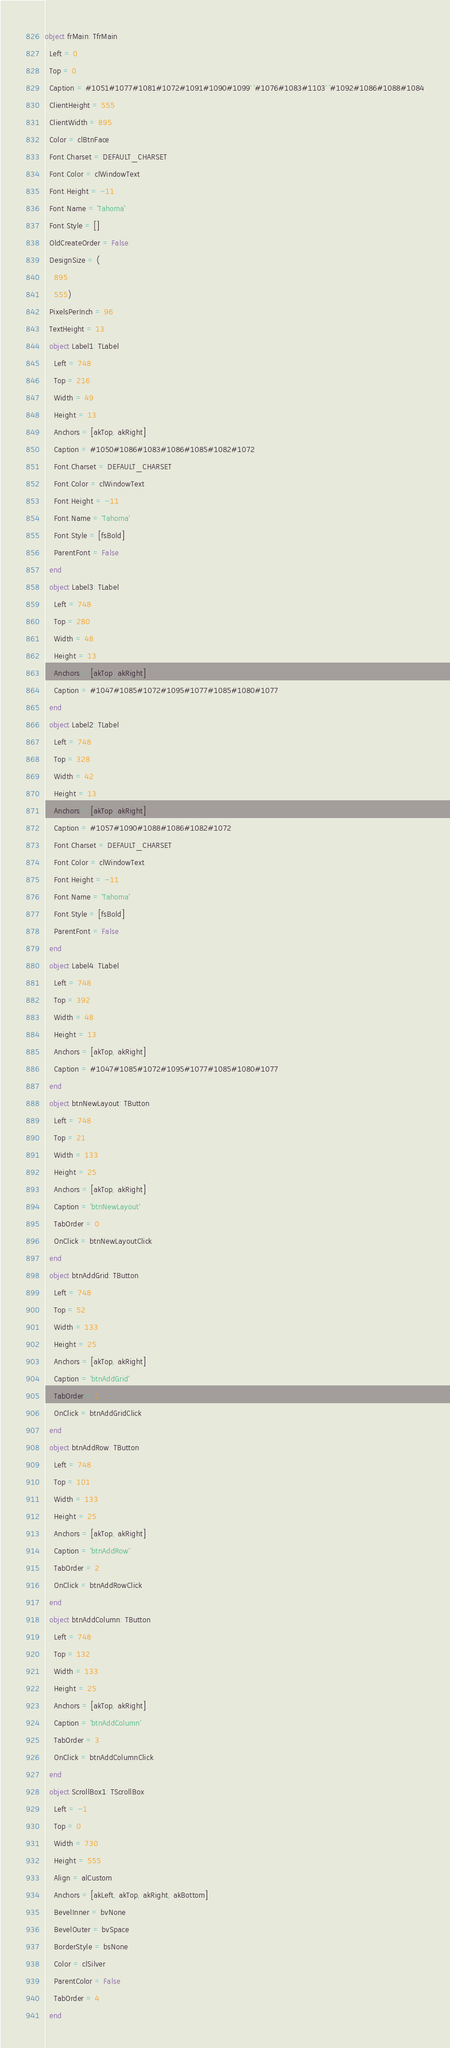Convert code to text. <code><loc_0><loc_0><loc_500><loc_500><_Pascal_>object frMain: TfrMain
  Left = 0
  Top = 0
  Caption = #1051#1077#1081#1072#1091#1090#1099' '#1076#1083#1103' '#1092#1086#1088#1084
  ClientHeight = 555
  ClientWidth = 895
  Color = clBtnFace
  Font.Charset = DEFAULT_CHARSET
  Font.Color = clWindowText
  Font.Height = -11
  Font.Name = 'Tahoma'
  Font.Style = []
  OldCreateOrder = False
  DesignSize = (
    895
    555)
  PixelsPerInch = 96
  TextHeight = 13
  object Label1: TLabel
    Left = 748
    Top = 216
    Width = 49
    Height = 13
    Anchors = [akTop, akRight]
    Caption = #1050#1086#1083#1086#1085#1082#1072
    Font.Charset = DEFAULT_CHARSET
    Font.Color = clWindowText
    Font.Height = -11
    Font.Name = 'Tahoma'
    Font.Style = [fsBold]
    ParentFont = False
  end
  object Label3: TLabel
    Left = 748
    Top = 280
    Width = 48
    Height = 13
    Anchors = [akTop, akRight]
    Caption = #1047#1085#1072#1095#1077#1085#1080#1077
  end
  object Label2: TLabel
    Left = 748
    Top = 328
    Width = 42
    Height = 13
    Anchors = [akTop, akRight]
    Caption = #1057#1090#1088#1086#1082#1072
    Font.Charset = DEFAULT_CHARSET
    Font.Color = clWindowText
    Font.Height = -11
    Font.Name = 'Tahoma'
    Font.Style = [fsBold]
    ParentFont = False
  end
  object Label4: TLabel
    Left = 748
    Top = 392
    Width = 48
    Height = 13
    Anchors = [akTop, akRight]
    Caption = #1047#1085#1072#1095#1077#1085#1080#1077
  end
  object btnNewLayout: TButton
    Left = 748
    Top = 21
    Width = 133
    Height = 25
    Anchors = [akTop, akRight]
    Caption = 'btnNewLayout'
    TabOrder = 0
    OnClick = btnNewLayoutClick
  end
  object btnAddGrid: TButton
    Left = 748
    Top = 52
    Width = 133
    Height = 25
    Anchors = [akTop, akRight]
    Caption = 'btnAddGrid'
    TabOrder = 1
    OnClick = btnAddGridClick
  end
  object btnAddRow: TButton
    Left = 748
    Top = 101
    Width = 133
    Height = 25
    Anchors = [akTop, akRight]
    Caption = 'btnAddRow'
    TabOrder = 2
    OnClick = btnAddRowClick
  end
  object btnAddColumn: TButton
    Left = 748
    Top = 132
    Width = 133
    Height = 25
    Anchors = [akTop, akRight]
    Caption = 'btnAddColumn'
    TabOrder = 3
    OnClick = btnAddColumnClick
  end
  object ScrollBox1: TScrollBox
    Left = -1
    Top = 0
    Width = 730
    Height = 555
    Align = alCustom
    Anchors = [akLeft, akTop, akRight, akBottom]
    BevelInner = bvNone
    BevelOuter = bvSpace
    BorderStyle = bsNone
    Color = clSilver
    ParentColor = False
    TabOrder = 4
  end</code> 